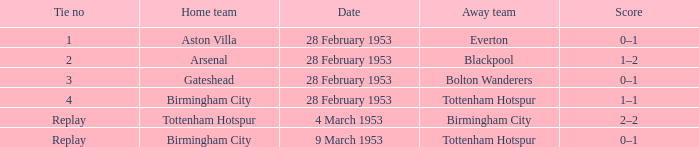Which Home team has an Away team of everton? Aston Villa. 